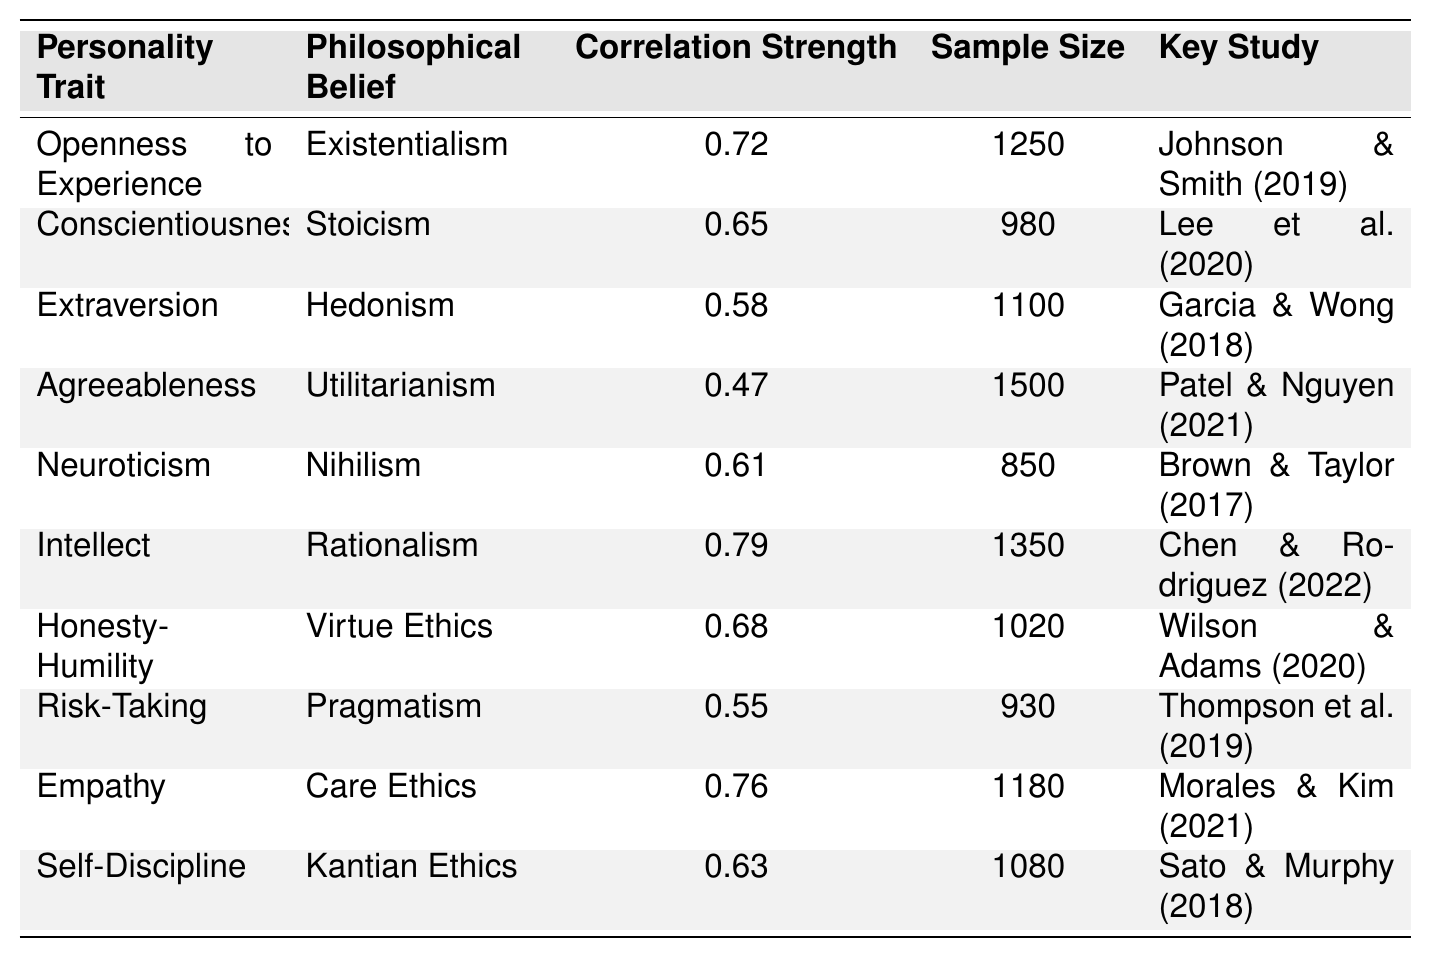What is the correlation strength between Openness to Experience and Existentialism? The table shows a specific correlation strength listed next to Openness to Experience and Existentialism. That value is 0.72.
Answer: 0.72 Which personality trait is most correlated with Rationalism? The table lists different personality traits and their corresponding philosophical beliefs. The highest correlation with Rationalism is from the Intellect trait, which has a correlation strength of 0.79.
Answer: Intellect Is there a correlation between Neuroticism and any philosophical belief? Yes, the table includes Neuroticism, which is correlated with Nihilism at a strength of 0.61.
Answer: Yes Which philosophical belief has the strongest correlation with Empathy? The table shows the correlation strength for Empathy is 0.76 with Care Ethics, making it the strongest correlation related to Empathy.
Answer: Care Ethics What is the average correlation strength of all personality traits listed in the table? First, we sum up all the correlation strengths: 0.72 + 0.65 + 0.58 + 0.47 + 0.61 + 0.79 + 0.68 + 0.55 + 0.76 + 0.63 = 6.44. Next, we divide by the number of traits, which is 10, leading to an average of 6.44 / 10 = 0.644.
Answer: 0.644 Is the correlation between Agreeableness and Utilitarianism stronger than the correlation between Risk-Taking and Pragmatism? The correlation for Agreeableness with Utilitarianism is 0.47, while for Risk-Taking with Pragmatism it is 0.55. Since 0.47 is less than 0.55, the correlation for Agreeableness is not stronger.
Answer: No How many studies support the correlation of Personality Traits with Philosophical Beliefs? By counting the unique entries in the "Key Study" column of the table, we find there are 10 studies listed, indicating support for the correlations.
Answer: 10 Which two personality traits are correlated with the highest correlation strength? The table shows that Intellect and Rationalism have the highest correlation strength of 0.79. No other traits exceed this value.
Answer: Intellect and Rationalism Is there a relationship between Self-Discipline and any philosophical belief? If so, what is the correlation strength? Yes, the table indicates that Self-Discipline is correlated with Kantian Ethics, with a reported correlation strength of 0.63.
Answer: Yes, 0.63 Compare the correlation strengths of Honesty-Humility and Conscientiousness with their respective philosophical beliefs. Which is stronger? The correlation for Honesty-Humility with Virtue Ethics is 0.68, while the correlation for Conscientiousness with Stoicism is 0.65. Since 0.68 is greater than 0.65, Honesty-Humility has a stronger correlation.
Answer: Honesty-Humility 